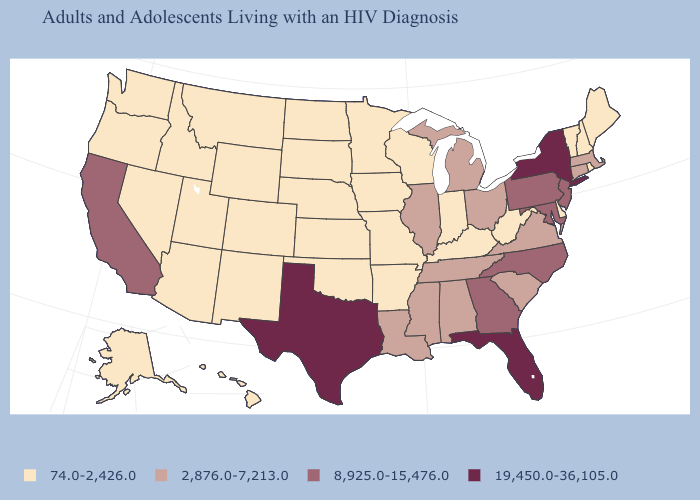Does the map have missing data?
Be succinct. No. Which states hav the highest value in the South?
Quick response, please. Florida, Texas. Name the states that have a value in the range 74.0-2,426.0?
Write a very short answer. Alaska, Arizona, Arkansas, Colorado, Delaware, Hawaii, Idaho, Indiana, Iowa, Kansas, Kentucky, Maine, Minnesota, Missouri, Montana, Nebraska, Nevada, New Hampshire, New Mexico, North Dakota, Oklahoma, Oregon, Rhode Island, South Dakota, Utah, Vermont, Washington, West Virginia, Wisconsin, Wyoming. What is the value of Texas?
Give a very brief answer. 19,450.0-36,105.0. Is the legend a continuous bar?
Keep it brief. No. Which states hav the highest value in the Northeast?
Keep it brief. New York. What is the value of Indiana?
Answer briefly. 74.0-2,426.0. Name the states that have a value in the range 2,876.0-7,213.0?
Short answer required. Alabama, Connecticut, Illinois, Louisiana, Massachusetts, Michigan, Mississippi, Ohio, South Carolina, Tennessee, Virginia. What is the lowest value in the South?
Quick response, please. 74.0-2,426.0. Does Rhode Island have a lower value than Massachusetts?
Give a very brief answer. Yes. What is the value of Kansas?
Give a very brief answer. 74.0-2,426.0. What is the value of Georgia?
Be succinct. 8,925.0-15,476.0. Does Florida have the lowest value in the USA?
Concise answer only. No. What is the value of Virginia?
Answer briefly. 2,876.0-7,213.0. What is the value of California?
Be succinct. 8,925.0-15,476.0. 